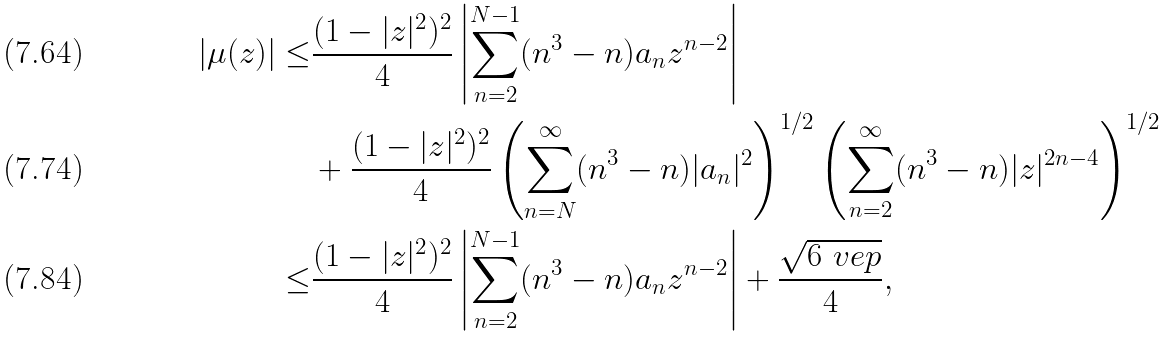Convert formula to latex. <formula><loc_0><loc_0><loc_500><loc_500>| \mu ( z ) | \leq & \frac { ( 1 - | z | ^ { 2 } ) ^ { 2 } } { 4 } \left | \sum _ { n = 2 } ^ { N - 1 } ( n ^ { 3 } - n ) a _ { n } z ^ { n - 2 } \right | \\ & + \frac { ( 1 - | z | ^ { 2 } ) ^ { 2 } } { 4 } \left ( \sum _ { n = N } ^ { \infty } ( n ^ { 3 } - n ) | a _ { n } | ^ { 2 } \right ) ^ { 1 / 2 } \left ( \sum _ { n = 2 } ^ { \infty } ( n ^ { 3 } - n ) | z | ^ { 2 n - 4 } \right ) ^ { 1 / 2 } \\ \leq & \frac { ( 1 - | z | ^ { 2 } ) ^ { 2 } } { 4 } \left | \sum _ { n = 2 } ^ { N - 1 } ( n ^ { 3 } - n ) a _ { n } z ^ { n - 2 } \right | + \frac { \sqrt { 6 \ v e p } } { 4 } ,</formula> 